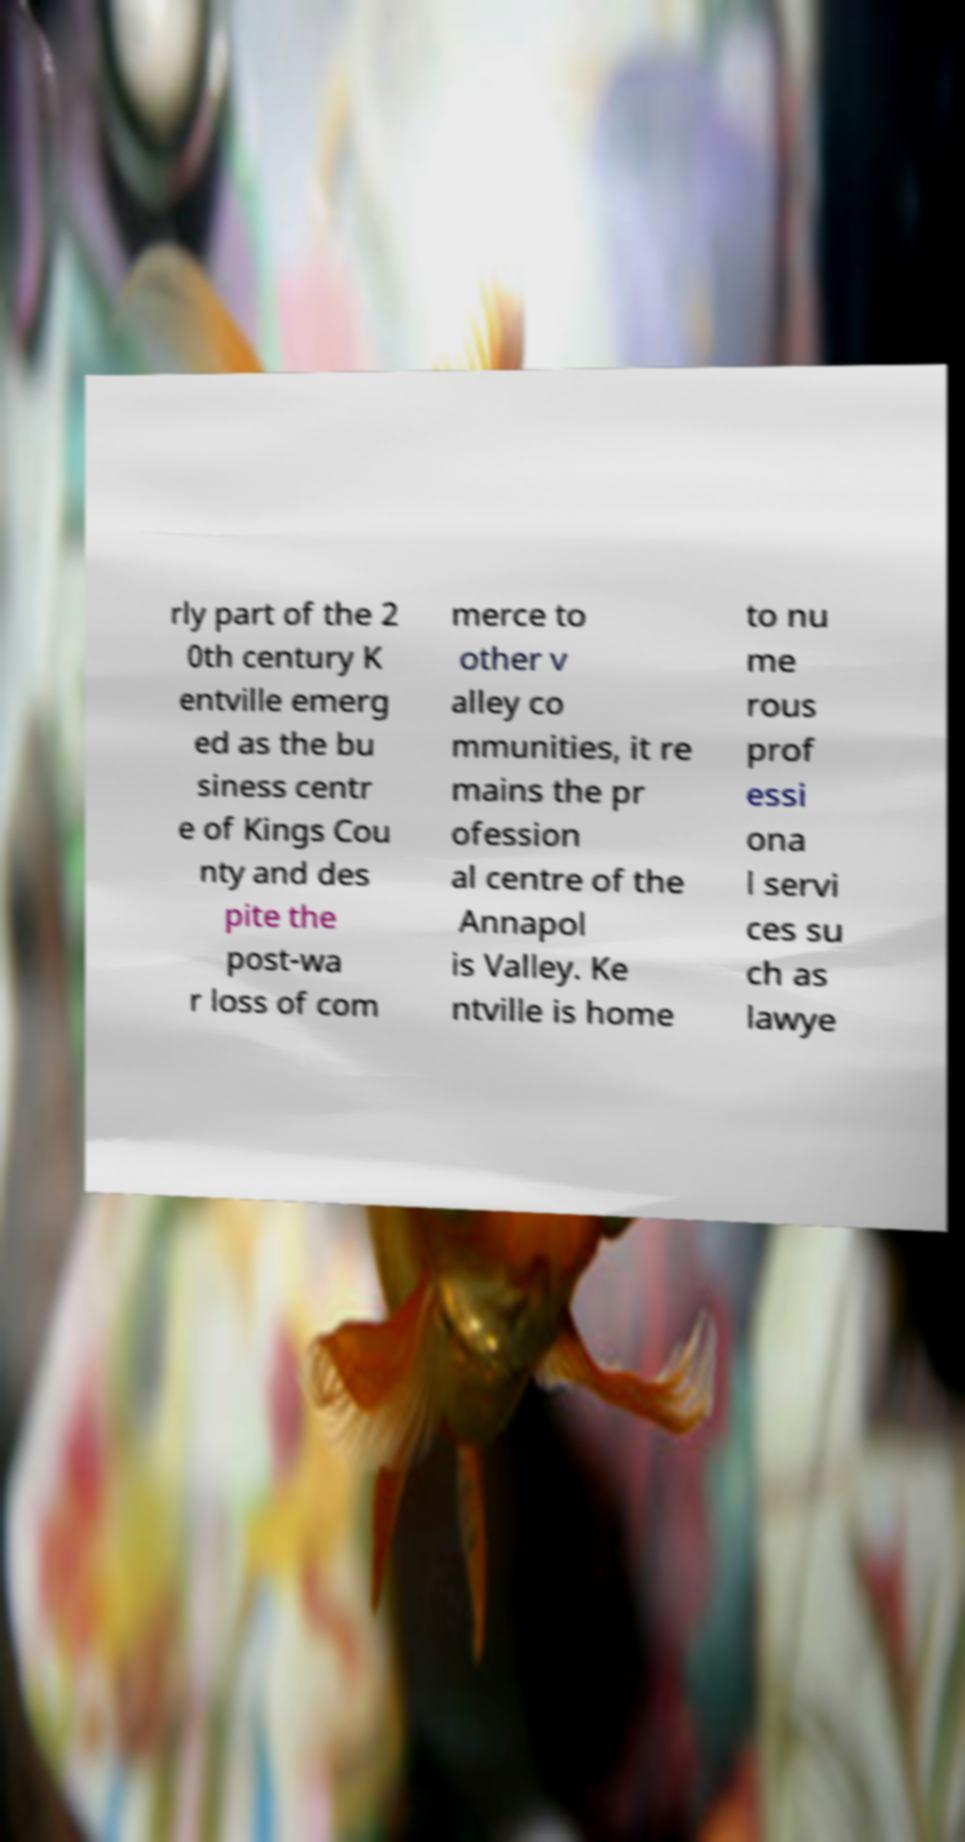What messages or text are displayed in this image? I need them in a readable, typed format. rly part of the 2 0th century K entville emerg ed as the bu siness centr e of Kings Cou nty and des pite the post-wa r loss of com merce to other v alley co mmunities, it re mains the pr ofession al centre of the Annapol is Valley. Ke ntville is home to nu me rous prof essi ona l servi ces su ch as lawye 